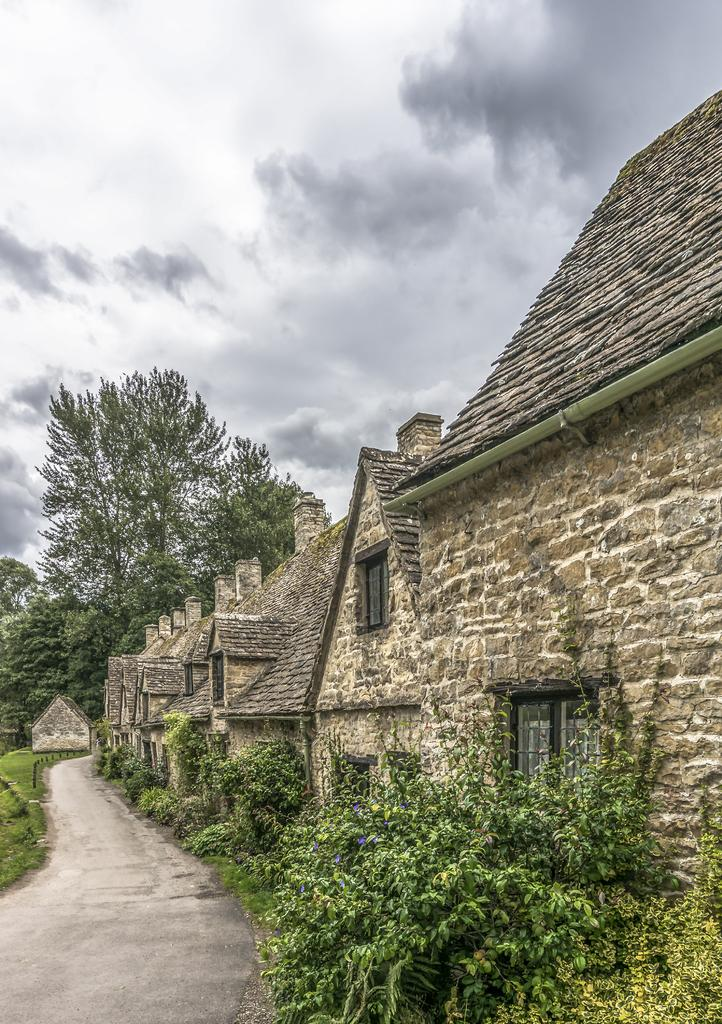What type of structures can be seen in the image? There are houses in the image. What type of vegetation is present in the image? There are trees in the image. What can be seen in the sky in the image? Clouds are visible in the image. Who is the manager of the garden in the image? There is no garden or manager mentioned in the image; it only features houses, trees, and clouds. 